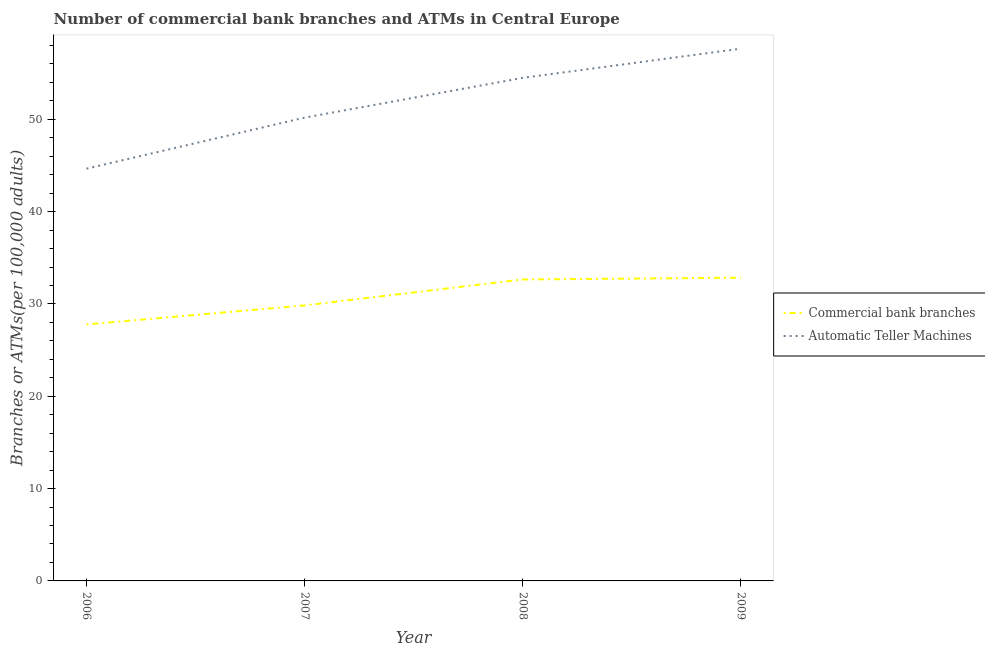Does the line corresponding to number of commercal bank branches intersect with the line corresponding to number of atms?
Provide a short and direct response. No. Is the number of lines equal to the number of legend labels?
Provide a succinct answer. Yes. What is the number of commercal bank branches in 2007?
Make the answer very short. 29.84. Across all years, what is the maximum number of commercal bank branches?
Provide a short and direct response. 32.84. Across all years, what is the minimum number of atms?
Keep it short and to the point. 44.65. In which year was the number of commercal bank branches minimum?
Make the answer very short. 2006. What is the total number of atms in the graph?
Your answer should be very brief. 206.97. What is the difference between the number of commercal bank branches in 2007 and that in 2008?
Give a very brief answer. -2.81. What is the difference between the number of commercal bank branches in 2009 and the number of atms in 2008?
Ensure brevity in your answer.  -21.65. What is the average number of commercal bank branches per year?
Provide a short and direct response. 30.78. In the year 2006, what is the difference between the number of atms and number of commercal bank branches?
Offer a terse response. 16.87. What is the ratio of the number of commercal bank branches in 2006 to that in 2007?
Offer a terse response. 0.93. Is the number of commercal bank branches in 2006 less than that in 2009?
Offer a very short reply. Yes. Is the difference between the number of commercal bank branches in 2007 and 2008 greater than the difference between the number of atms in 2007 and 2008?
Offer a very short reply. Yes. What is the difference between the highest and the second highest number of commercal bank branches?
Ensure brevity in your answer.  0.19. What is the difference between the highest and the lowest number of commercal bank branches?
Make the answer very short. 5.06. Is the number of commercal bank branches strictly greater than the number of atms over the years?
Provide a short and direct response. No. How many lines are there?
Provide a succinct answer. 2. How many years are there in the graph?
Offer a terse response. 4. Does the graph contain any zero values?
Give a very brief answer. No. How many legend labels are there?
Offer a terse response. 2. What is the title of the graph?
Provide a succinct answer. Number of commercial bank branches and ATMs in Central Europe. Does "Stunting" appear as one of the legend labels in the graph?
Provide a short and direct response. No. What is the label or title of the Y-axis?
Your response must be concise. Branches or ATMs(per 100,0 adults). What is the Branches or ATMs(per 100,000 adults) of Commercial bank branches in 2006?
Ensure brevity in your answer.  27.78. What is the Branches or ATMs(per 100,000 adults) in Automatic Teller Machines in 2006?
Offer a terse response. 44.65. What is the Branches or ATMs(per 100,000 adults) in Commercial bank branches in 2007?
Provide a succinct answer. 29.84. What is the Branches or ATMs(per 100,000 adults) of Automatic Teller Machines in 2007?
Keep it short and to the point. 50.18. What is the Branches or ATMs(per 100,000 adults) in Commercial bank branches in 2008?
Offer a very short reply. 32.65. What is the Branches or ATMs(per 100,000 adults) of Automatic Teller Machines in 2008?
Give a very brief answer. 54.49. What is the Branches or ATMs(per 100,000 adults) of Commercial bank branches in 2009?
Keep it short and to the point. 32.84. What is the Branches or ATMs(per 100,000 adults) of Automatic Teller Machines in 2009?
Give a very brief answer. 57.65. Across all years, what is the maximum Branches or ATMs(per 100,000 adults) of Commercial bank branches?
Your answer should be very brief. 32.84. Across all years, what is the maximum Branches or ATMs(per 100,000 adults) of Automatic Teller Machines?
Make the answer very short. 57.65. Across all years, what is the minimum Branches or ATMs(per 100,000 adults) in Commercial bank branches?
Your answer should be compact. 27.78. Across all years, what is the minimum Branches or ATMs(per 100,000 adults) in Automatic Teller Machines?
Make the answer very short. 44.65. What is the total Branches or ATMs(per 100,000 adults) in Commercial bank branches in the graph?
Your answer should be compact. 123.12. What is the total Branches or ATMs(per 100,000 adults) in Automatic Teller Machines in the graph?
Offer a terse response. 206.97. What is the difference between the Branches or ATMs(per 100,000 adults) of Commercial bank branches in 2006 and that in 2007?
Offer a terse response. -2.06. What is the difference between the Branches or ATMs(per 100,000 adults) in Automatic Teller Machines in 2006 and that in 2007?
Make the answer very short. -5.53. What is the difference between the Branches or ATMs(per 100,000 adults) in Commercial bank branches in 2006 and that in 2008?
Provide a short and direct response. -4.87. What is the difference between the Branches or ATMs(per 100,000 adults) in Automatic Teller Machines in 2006 and that in 2008?
Your response must be concise. -9.84. What is the difference between the Branches or ATMs(per 100,000 adults) in Commercial bank branches in 2006 and that in 2009?
Your answer should be very brief. -5.06. What is the difference between the Branches or ATMs(per 100,000 adults) in Automatic Teller Machines in 2006 and that in 2009?
Offer a very short reply. -13. What is the difference between the Branches or ATMs(per 100,000 adults) in Commercial bank branches in 2007 and that in 2008?
Make the answer very short. -2.81. What is the difference between the Branches or ATMs(per 100,000 adults) of Automatic Teller Machines in 2007 and that in 2008?
Provide a succinct answer. -4.31. What is the difference between the Branches or ATMs(per 100,000 adults) in Commercial bank branches in 2007 and that in 2009?
Provide a succinct answer. -3. What is the difference between the Branches or ATMs(per 100,000 adults) of Automatic Teller Machines in 2007 and that in 2009?
Provide a short and direct response. -7.47. What is the difference between the Branches or ATMs(per 100,000 adults) in Commercial bank branches in 2008 and that in 2009?
Provide a short and direct response. -0.19. What is the difference between the Branches or ATMs(per 100,000 adults) in Automatic Teller Machines in 2008 and that in 2009?
Provide a succinct answer. -3.16. What is the difference between the Branches or ATMs(per 100,000 adults) of Commercial bank branches in 2006 and the Branches or ATMs(per 100,000 adults) of Automatic Teller Machines in 2007?
Offer a terse response. -22.4. What is the difference between the Branches or ATMs(per 100,000 adults) in Commercial bank branches in 2006 and the Branches or ATMs(per 100,000 adults) in Automatic Teller Machines in 2008?
Provide a short and direct response. -26.71. What is the difference between the Branches or ATMs(per 100,000 adults) of Commercial bank branches in 2006 and the Branches or ATMs(per 100,000 adults) of Automatic Teller Machines in 2009?
Make the answer very short. -29.87. What is the difference between the Branches or ATMs(per 100,000 adults) in Commercial bank branches in 2007 and the Branches or ATMs(per 100,000 adults) in Automatic Teller Machines in 2008?
Ensure brevity in your answer.  -24.64. What is the difference between the Branches or ATMs(per 100,000 adults) in Commercial bank branches in 2007 and the Branches or ATMs(per 100,000 adults) in Automatic Teller Machines in 2009?
Offer a terse response. -27.81. What is the difference between the Branches or ATMs(per 100,000 adults) of Commercial bank branches in 2008 and the Branches or ATMs(per 100,000 adults) of Automatic Teller Machines in 2009?
Make the answer very short. -25. What is the average Branches or ATMs(per 100,000 adults) in Commercial bank branches per year?
Ensure brevity in your answer.  30.78. What is the average Branches or ATMs(per 100,000 adults) in Automatic Teller Machines per year?
Make the answer very short. 51.74. In the year 2006, what is the difference between the Branches or ATMs(per 100,000 adults) of Commercial bank branches and Branches or ATMs(per 100,000 adults) of Automatic Teller Machines?
Your response must be concise. -16.87. In the year 2007, what is the difference between the Branches or ATMs(per 100,000 adults) in Commercial bank branches and Branches or ATMs(per 100,000 adults) in Automatic Teller Machines?
Your answer should be very brief. -20.34. In the year 2008, what is the difference between the Branches or ATMs(per 100,000 adults) in Commercial bank branches and Branches or ATMs(per 100,000 adults) in Automatic Teller Machines?
Provide a short and direct response. -21.84. In the year 2009, what is the difference between the Branches or ATMs(per 100,000 adults) of Commercial bank branches and Branches or ATMs(per 100,000 adults) of Automatic Teller Machines?
Give a very brief answer. -24.81. What is the ratio of the Branches or ATMs(per 100,000 adults) of Commercial bank branches in 2006 to that in 2007?
Make the answer very short. 0.93. What is the ratio of the Branches or ATMs(per 100,000 adults) in Automatic Teller Machines in 2006 to that in 2007?
Ensure brevity in your answer.  0.89. What is the ratio of the Branches or ATMs(per 100,000 adults) in Commercial bank branches in 2006 to that in 2008?
Provide a succinct answer. 0.85. What is the ratio of the Branches or ATMs(per 100,000 adults) in Automatic Teller Machines in 2006 to that in 2008?
Offer a very short reply. 0.82. What is the ratio of the Branches or ATMs(per 100,000 adults) in Commercial bank branches in 2006 to that in 2009?
Your answer should be compact. 0.85. What is the ratio of the Branches or ATMs(per 100,000 adults) of Automatic Teller Machines in 2006 to that in 2009?
Provide a short and direct response. 0.77. What is the ratio of the Branches or ATMs(per 100,000 adults) of Commercial bank branches in 2007 to that in 2008?
Your answer should be compact. 0.91. What is the ratio of the Branches or ATMs(per 100,000 adults) in Automatic Teller Machines in 2007 to that in 2008?
Provide a succinct answer. 0.92. What is the ratio of the Branches or ATMs(per 100,000 adults) of Commercial bank branches in 2007 to that in 2009?
Give a very brief answer. 0.91. What is the ratio of the Branches or ATMs(per 100,000 adults) of Automatic Teller Machines in 2007 to that in 2009?
Make the answer very short. 0.87. What is the ratio of the Branches or ATMs(per 100,000 adults) in Commercial bank branches in 2008 to that in 2009?
Provide a short and direct response. 0.99. What is the ratio of the Branches or ATMs(per 100,000 adults) in Automatic Teller Machines in 2008 to that in 2009?
Your answer should be very brief. 0.95. What is the difference between the highest and the second highest Branches or ATMs(per 100,000 adults) in Commercial bank branches?
Keep it short and to the point. 0.19. What is the difference between the highest and the second highest Branches or ATMs(per 100,000 adults) in Automatic Teller Machines?
Make the answer very short. 3.16. What is the difference between the highest and the lowest Branches or ATMs(per 100,000 adults) in Commercial bank branches?
Ensure brevity in your answer.  5.06. What is the difference between the highest and the lowest Branches or ATMs(per 100,000 adults) of Automatic Teller Machines?
Make the answer very short. 13. 